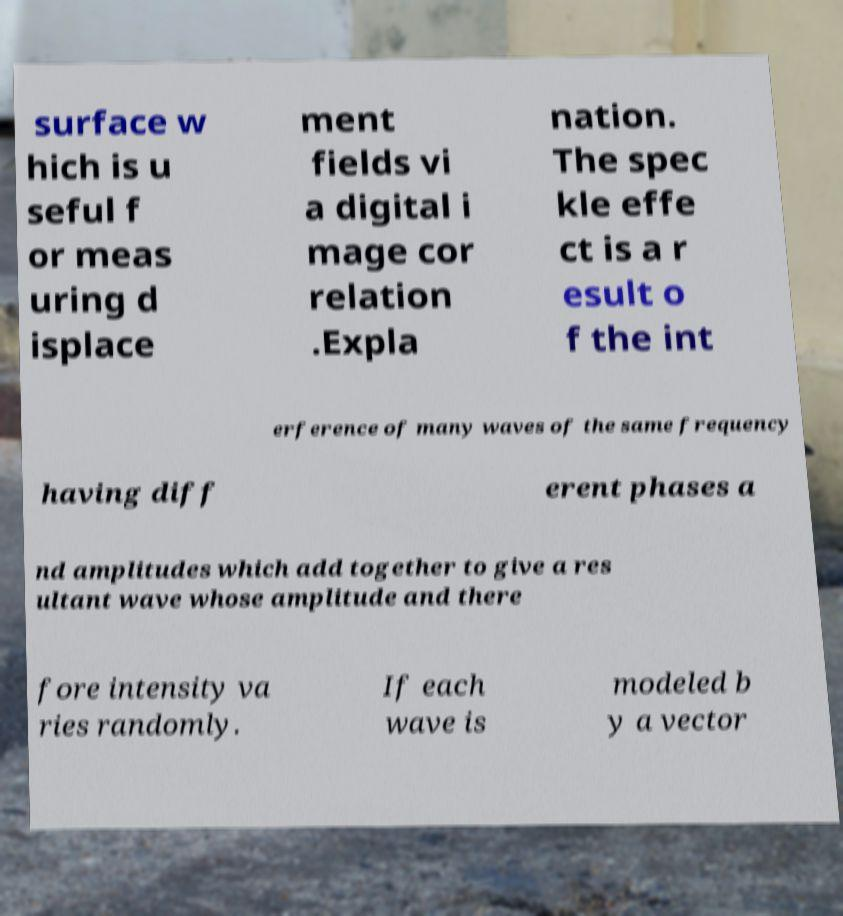Please read and relay the text visible in this image. What does it say? surface w hich is u seful f or meas uring d isplace ment fields vi a digital i mage cor relation .Expla nation. The spec kle effe ct is a r esult o f the int erference of many waves of the same frequency having diff erent phases a nd amplitudes which add together to give a res ultant wave whose amplitude and there fore intensity va ries randomly. If each wave is modeled b y a vector 